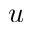Convert formula to latex. <formula><loc_0><loc_0><loc_500><loc_500>u</formula> 